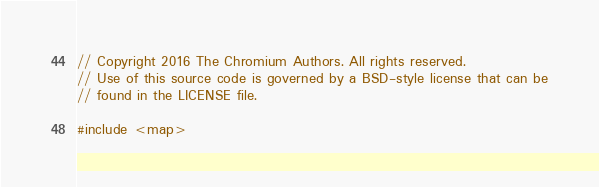Convert code to text. <code><loc_0><loc_0><loc_500><loc_500><_ObjectiveC_>// Copyright 2016 The Chromium Authors. All rights reserved.
// Use of this source code is governed by a BSD-style license that can be
// found in the LICENSE file.

#include <map>
</code> 